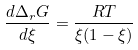<formula> <loc_0><loc_0><loc_500><loc_500>\frac { d \Delta _ { r } G } { d \xi } = \frac { R T } { \xi ( 1 - \xi ) }</formula> 